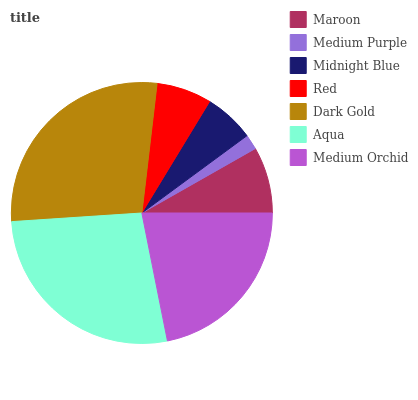Is Medium Purple the minimum?
Answer yes or no. Yes. Is Dark Gold the maximum?
Answer yes or no. Yes. Is Midnight Blue the minimum?
Answer yes or no. No. Is Midnight Blue the maximum?
Answer yes or no. No. Is Midnight Blue greater than Medium Purple?
Answer yes or no. Yes. Is Medium Purple less than Midnight Blue?
Answer yes or no. Yes. Is Medium Purple greater than Midnight Blue?
Answer yes or no. No. Is Midnight Blue less than Medium Purple?
Answer yes or no. No. Is Maroon the high median?
Answer yes or no. Yes. Is Maroon the low median?
Answer yes or no. Yes. Is Medium Orchid the high median?
Answer yes or no. No. Is Aqua the low median?
Answer yes or no. No. 